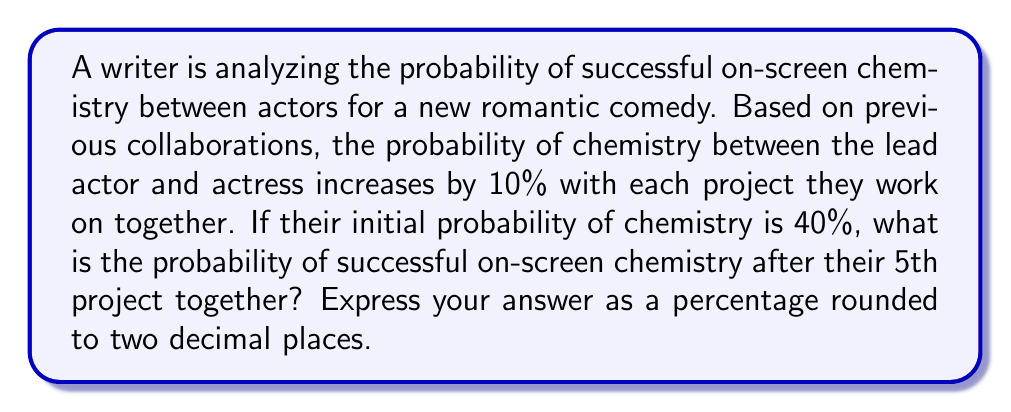Give your solution to this math problem. Let's approach this step-by-step:

1) Let $p_n$ be the probability of chemistry after the $n$-th project.
2) The initial probability is $p_0 = 40\% = 0.4$
3) Each project increases the probability by 10% of the previous probability.
4) We can express this as a geometric sequence:

   $p_n = p_{n-1} + 0.1p_{n-1} = 1.1p_{n-1}$

5) This leads to the general term:

   $p_n = p_0 \cdot (1.1)^n$

6) For the 5th project, $n = 5$:

   $p_5 = 0.4 \cdot (1.1)^5$

7) Calculate:
   $$\begin{align}
   p_5 &= 0.4 \cdot (1.1)^5 \\
   &= 0.4 \cdot 1.6105100 \\
   &= 0.64420400
   \end{align}$$

8) Convert to percentage and round to two decimal places:
   $0.64420400 \cdot 100\% \approx 64.42\%$
Answer: 64.42% 